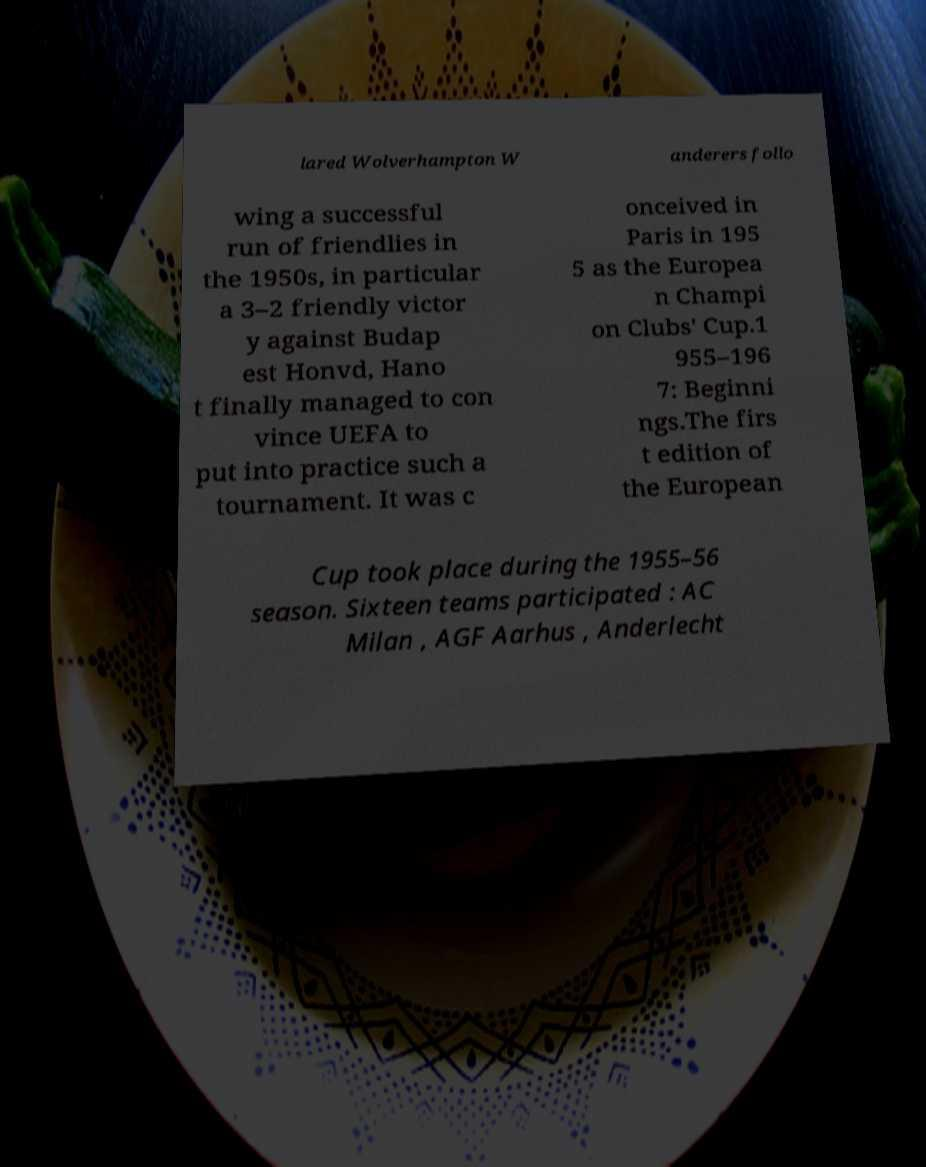I need the written content from this picture converted into text. Can you do that? lared Wolverhampton W anderers follo wing a successful run of friendlies in the 1950s, in particular a 3–2 friendly victor y against Budap est Honvd, Hano t finally managed to con vince UEFA to put into practice such a tournament. It was c onceived in Paris in 195 5 as the Europea n Champi on Clubs' Cup.1 955–196 7: Beginni ngs.The firs t edition of the European Cup took place during the 1955–56 season. Sixteen teams participated : AC Milan , AGF Aarhus , Anderlecht 